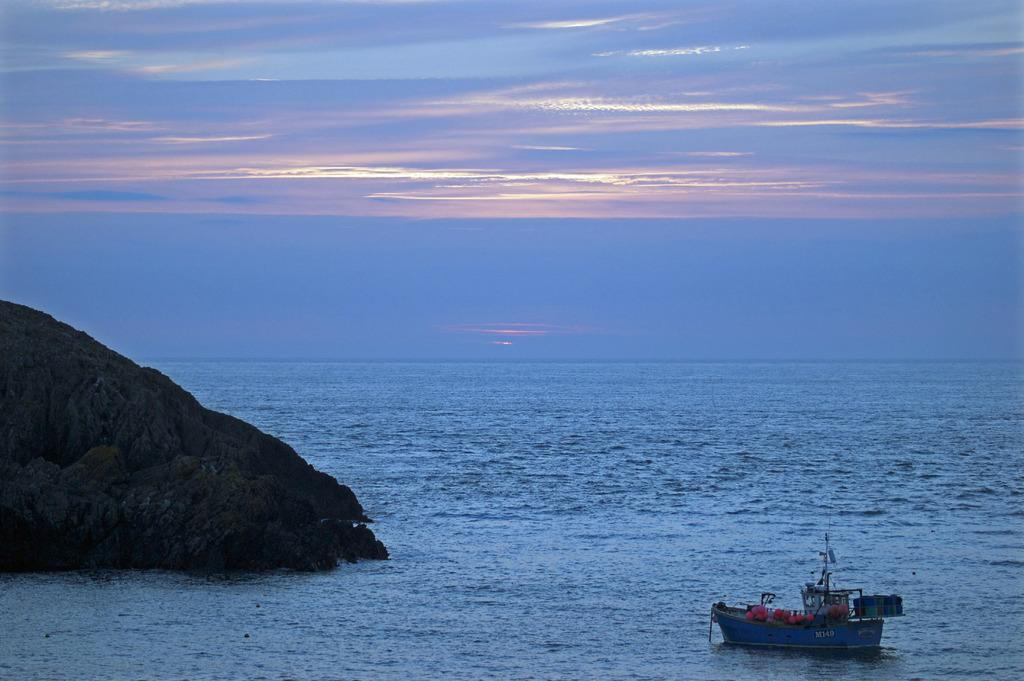What is the main subject of the image? The main subject of the image is a ship. Where is the ship located in the image? The ship is on the water in the image. What can be seen on the left side of the image? There is a mountain on the left side of the image. What is visible at the top of the image? The sky is visible at the top of the image. How many firemen are on the ship in the image? There is no mention of firemen or any people in the image; it only features a ship, water, a mountain, and the sky. 